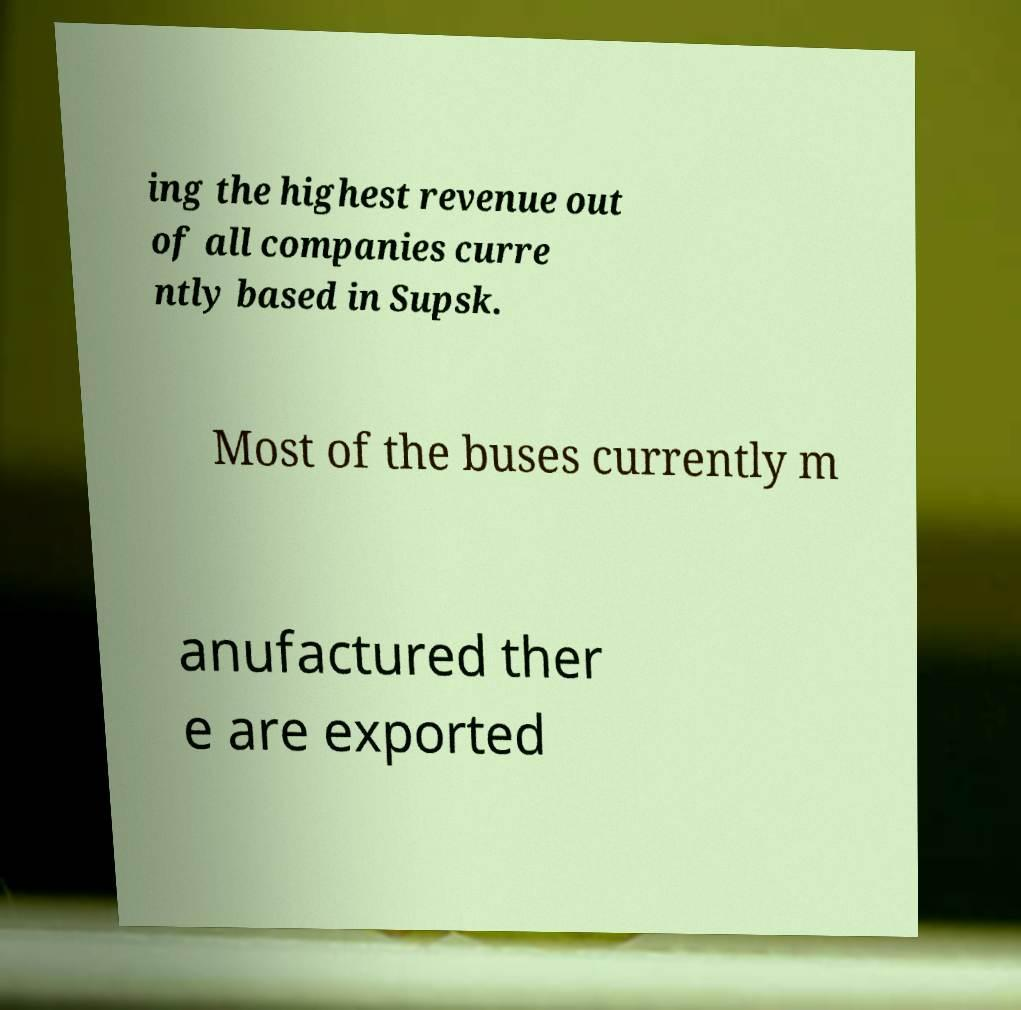What messages or text are displayed in this image? I need them in a readable, typed format. ing the highest revenue out of all companies curre ntly based in Supsk. Most of the buses currently m anufactured ther e are exported 